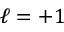Convert formula to latex. <formula><loc_0><loc_0><loc_500><loc_500>\ell = + 1</formula> 